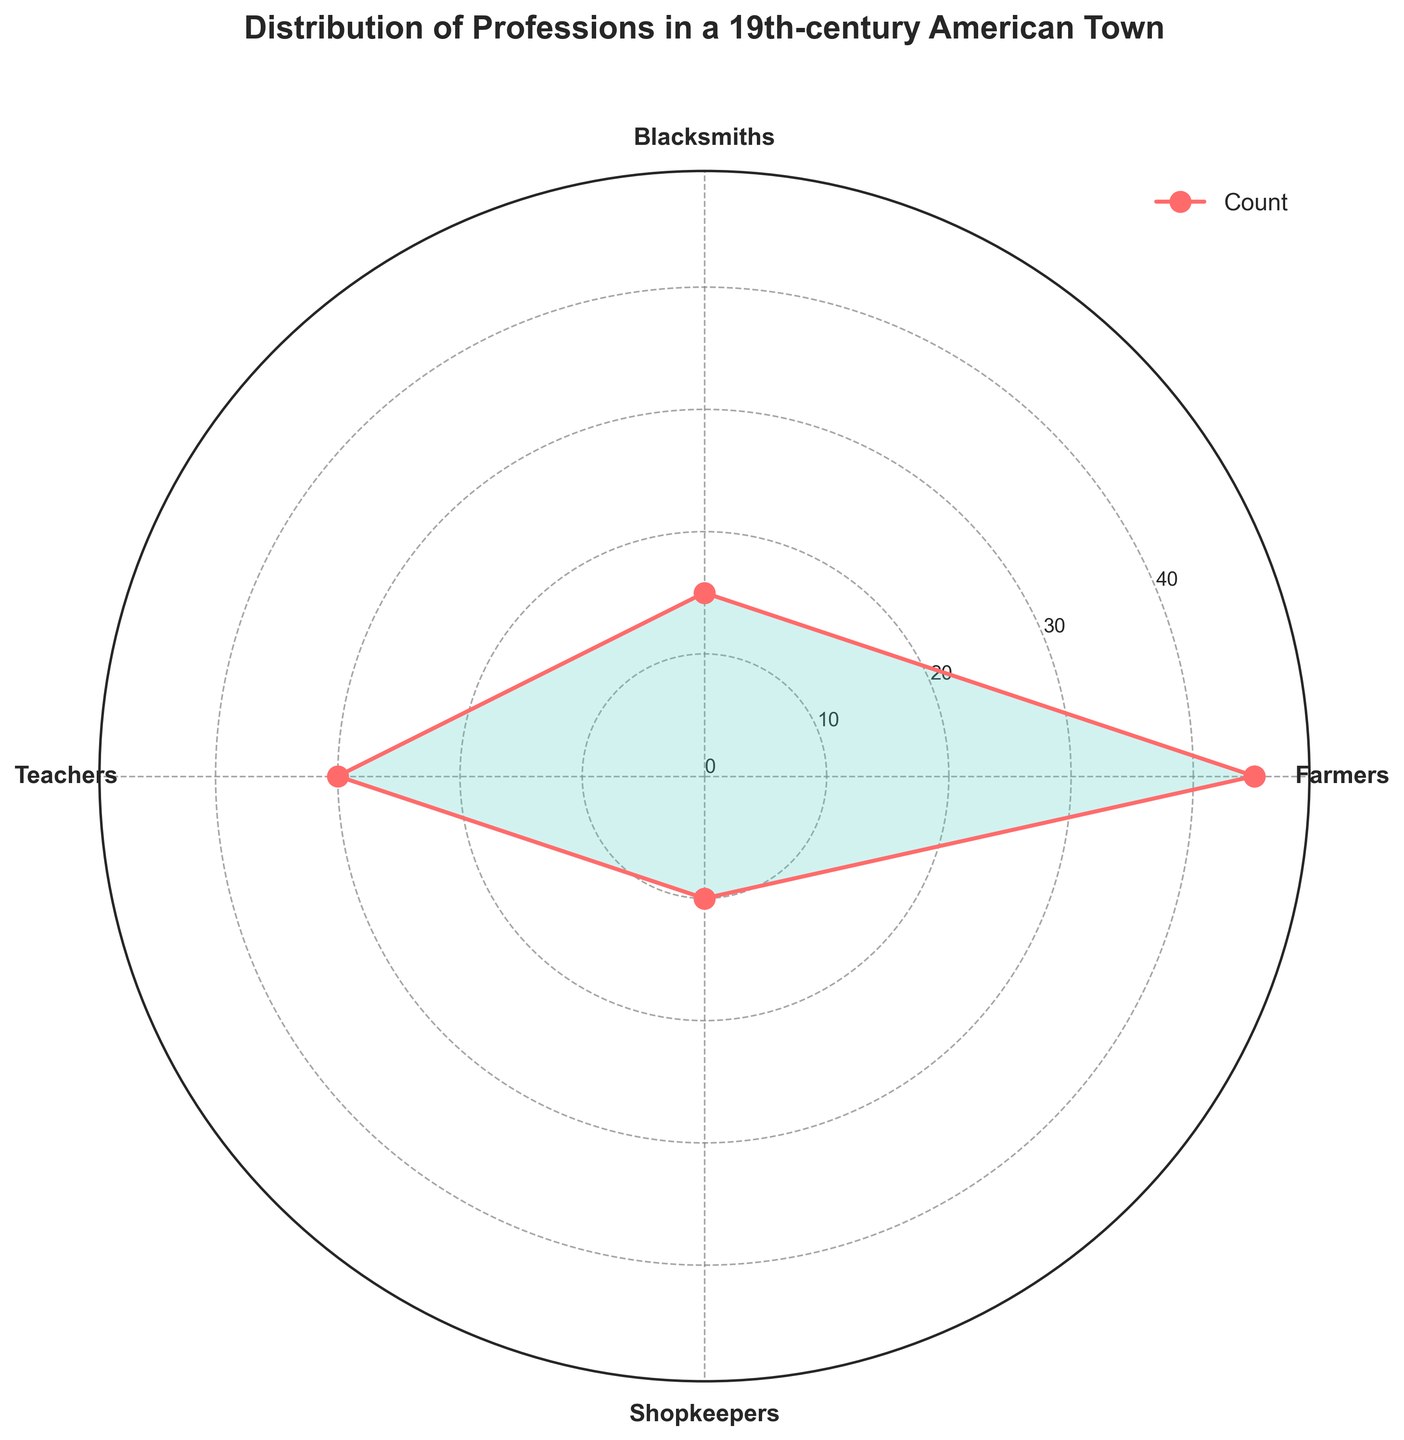What is the title of the rose chart? The title is positioned at the top of the figure, indicating the overall topic that the chart represents.
Answer: Distribution of Professions in a 19th-century American Town How many professions are displayed in the chart? To determine the number of professions, count the distinct labels on the circumference of the rose chart.
Answer: 4 What profession has the highest count? To find the profession with the highest count, identify which slice of the rose chart extends the farthest from the center.
Answer: Farmers What is the color of the shaded area representing the counts? Observe the filled area inside the rose chart, noting its specific color.
Answer: Light blue What is the average count of the professions? Add the counts of all professions and divide by the number of professions: (45 + 15 + 30 + 10) / 4 = 100 / 4
Answer: 25 How many more Farmers are there compared to Shopkeepers? Subtract the count of Shopkeepers from the count of Farmers: 45 - 10.
Answer: 35 Which profession has fewer counts than Teachers but more than Shopkeepers? Identify the profession with a count greater than 10 but less than 30 by examining the chart.
Answer: Blacksmiths What is the total count of Blacksmiths and Teachers combined? Add the counts of Blacksmiths and Teachers: 15 + 30.
Answer: 45 Do the counts of Farmers and Teachers combined surpass the total count of Blacksmiths and Shopkeepers? Add the counts of Farmers and Teachers (45 + 30) and compare with the sum of Blacksmiths and Shopkeepers (15 + 10): 75 versus 25.
Answer: Yes Why is there a need to use a rose chart for this data representation? The rose chart is particularly suited to display cyclic data, using angles to represent the distinct groups while the radius indicates the count, allowing for an intuitive visual comparison of the different professions.
Answer: To visually compare the distribution of different professions efficiently 